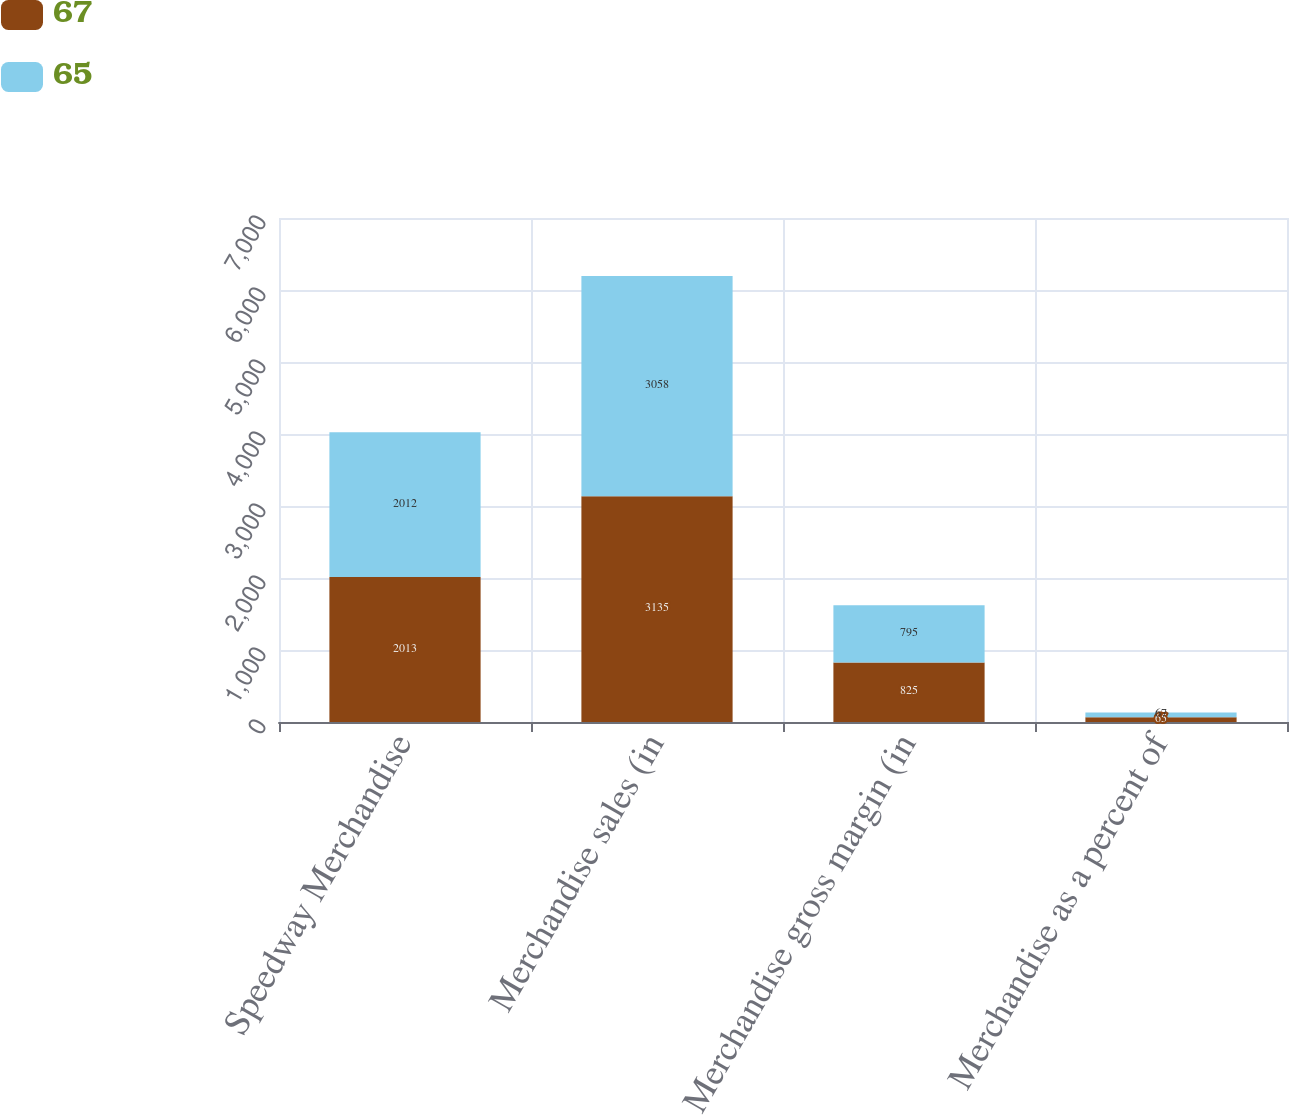Convert chart. <chart><loc_0><loc_0><loc_500><loc_500><stacked_bar_chart><ecel><fcel>Speedway Merchandise<fcel>Merchandise sales (in<fcel>Merchandise gross margin (in<fcel>Merchandise as a percent of<nl><fcel>67<fcel>2013<fcel>3135<fcel>825<fcel>65<nl><fcel>65<fcel>2012<fcel>3058<fcel>795<fcel>67<nl></chart> 